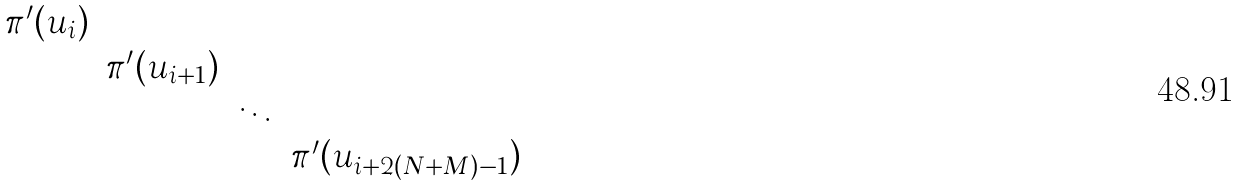<formula> <loc_0><loc_0><loc_500><loc_500>\begin{matrix} \pi ^ { \prime } ( u _ { i } ) \\ & \pi ^ { \prime } ( u _ { i + 1 } ) \\ & & \ddots \\ & & & \pi ^ { \prime } ( u _ { i + 2 ( N + M ) - 1 } ) \\ \end{matrix}</formula> 